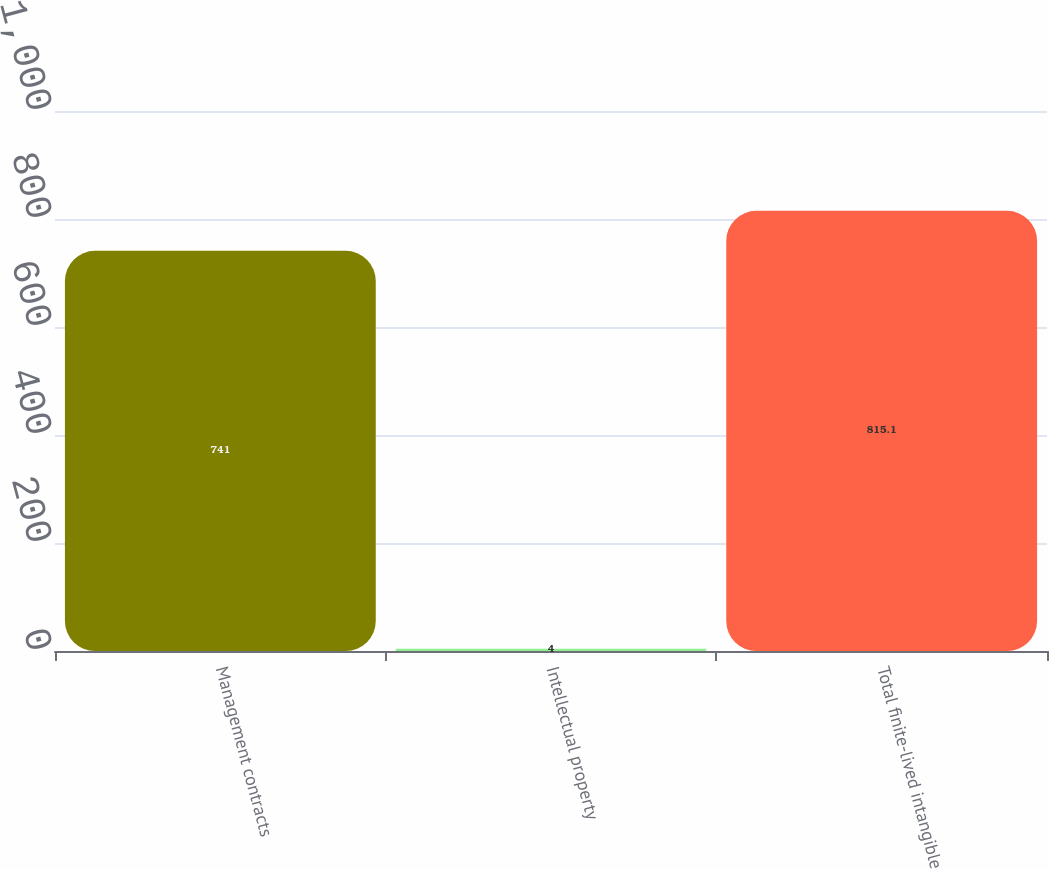<chart> <loc_0><loc_0><loc_500><loc_500><bar_chart><fcel>Management contracts<fcel>Intellectual property<fcel>Total finite-lived intangible<nl><fcel>741<fcel>4<fcel>815.1<nl></chart> 